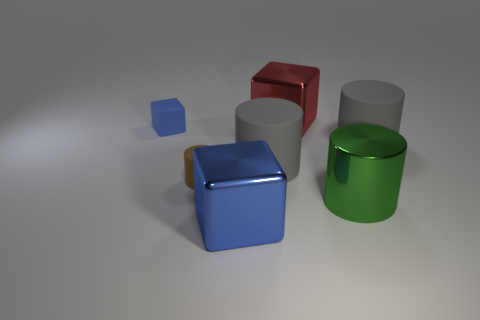Subtract all big cylinders. How many cylinders are left? 1 Subtract all green cylinders. How many cylinders are left? 3 Add 3 large blue metallic cylinders. How many objects exist? 10 Subtract all blue cylinders. Subtract all purple blocks. How many cylinders are left? 4 Subtract all cylinders. How many objects are left? 3 Subtract all large yellow things. Subtract all large green metallic cylinders. How many objects are left? 6 Add 3 large blue blocks. How many large blue blocks are left? 4 Add 5 big green cylinders. How many big green cylinders exist? 6 Subtract 0 red cylinders. How many objects are left? 7 